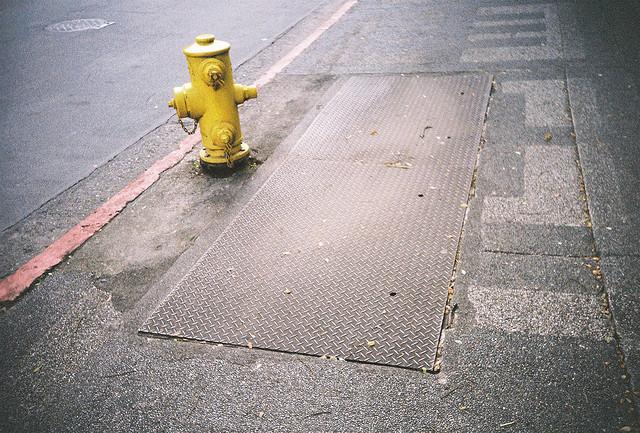What color is the curb painted?
Keep it brief. Red. Would a person be able to play the game "don't step on a crack" on this sidewalk?
Answer briefly. Yes. What color is the hydrant?
Answer briefly. Yellow. 